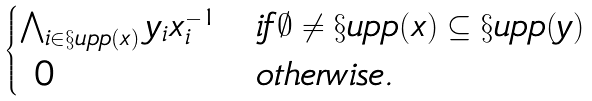<formula> <loc_0><loc_0><loc_500><loc_500>\begin{cases} \bigwedge _ { i \in \S u p p ( x ) } y _ { i } x _ { i } ^ { - 1 } & i f \emptyset \neq \S u p p ( x ) \subseteq \S u p p ( y ) \\ \ 0 & o t h e r w i s e . \end{cases}</formula> 